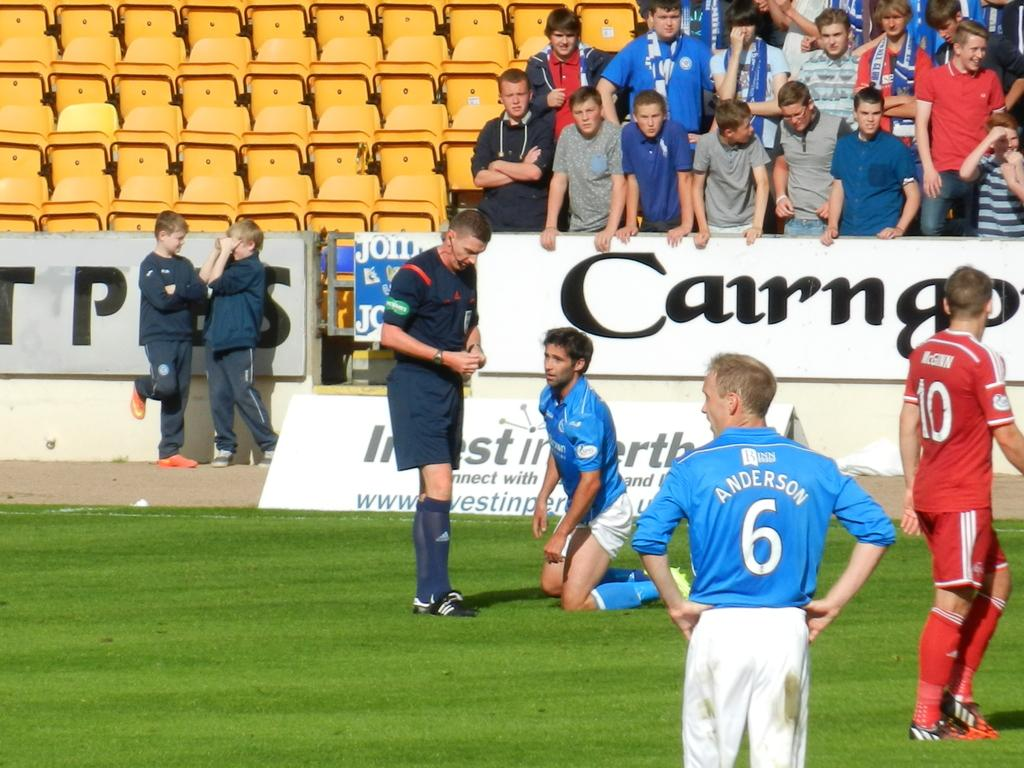How many people are present in the image? There are four people in the image. What type of surface is visible in the image? There is grass visible in the image. What can be seen in the background of the image? There are banners, people, and seats in the background of the image. What type of jam is being spread on the banners in the image? There is no jam present in the image; it features banners in the background. How many dogs are visible in the image? There are no dogs visible in the image. 